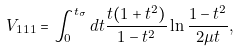Convert formula to latex. <formula><loc_0><loc_0><loc_500><loc_500>V _ { 1 1 1 } = \int _ { 0 } ^ { t _ { \sigma } } { d t } \frac { t ( 1 + t ^ { 2 } ) } { 1 - t ^ { 2 } } \ln { \frac { 1 - t ^ { 2 } } { 2 \mu t } } ,</formula> 